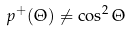<formula> <loc_0><loc_0><loc_500><loc_500>p ^ { + } ( \Theta ) \neq \cos ^ { 2 } \Theta</formula> 